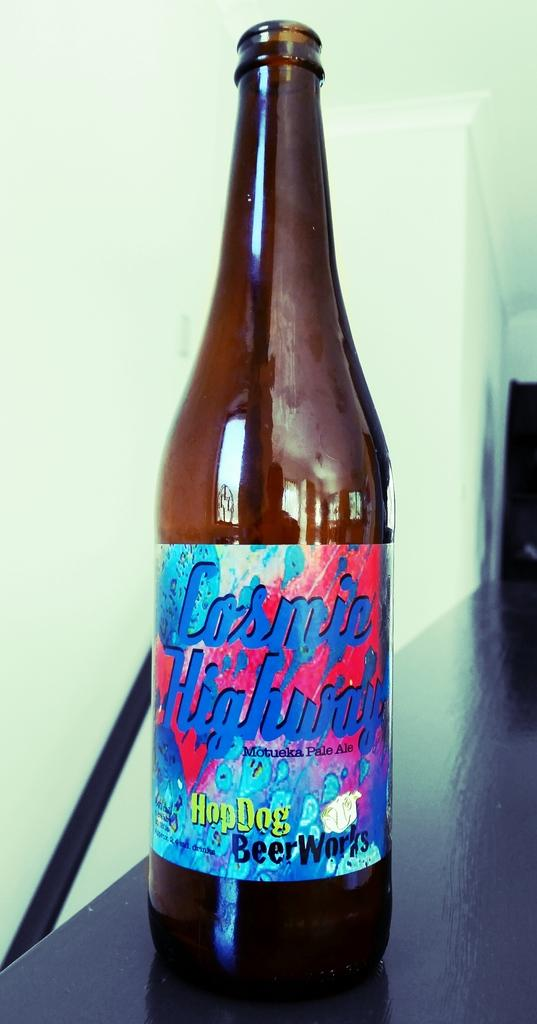<image>
Present a compact description of the photo's key features. Bottle of beer with a label that says HopDog Beer Works. 